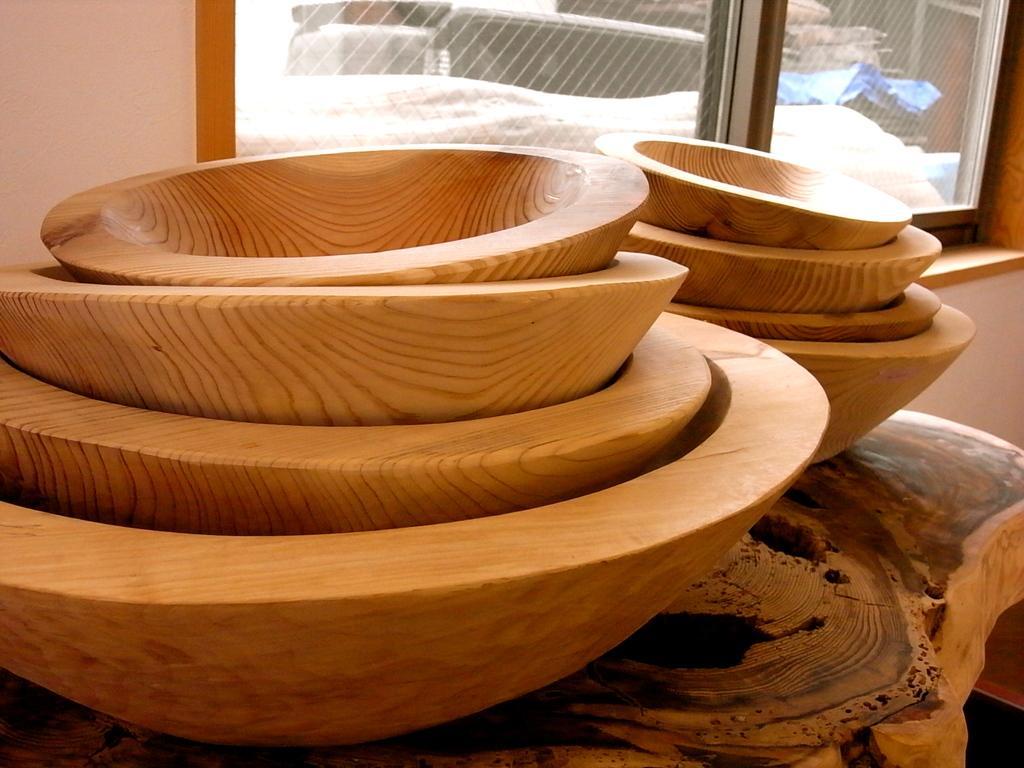In one or two sentences, can you explain what this image depicts? In this image I can see few wooden bowls in the front and in the background I can see a window. I can also see few stuffs through the window. 